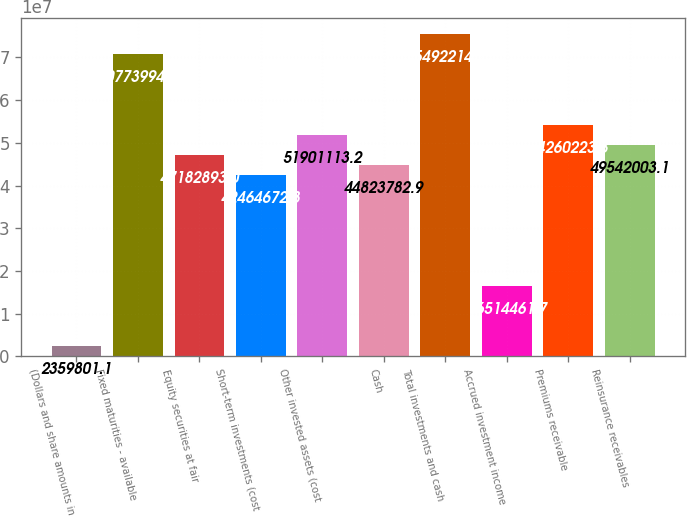Convert chart. <chart><loc_0><loc_0><loc_500><loc_500><bar_chart><fcel>(Dollars and share amounts in<fcel>Fixed maturities - available<fcel>Equity securities at fair<fcel>Short-term investments (cost<fcel>Other invested assets (cost<fcel>Cash<fcel>Total investments and cash<fcel>Accrued investment income<fcel>Premiums receivable<fcel>Reinsurance receivables<nl><fcel>2.3598e+06<fcel>7.0774e+07<fcel>4.71829e+07<fcel>4.24647e+07<fcel>5.19011e+07<fcel>4.48238e+07<fcel>7.54922e+07<fcel>1.65145e+07<fcel>5.42602e+07<fcel>4.9542e+07<nl></chart> 